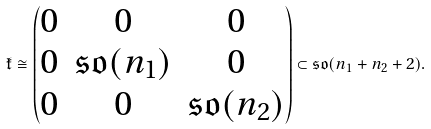<formula> <loc_0><loc_0><loc_500><loc_500>\mathfrak { k } \cong \begin{pmatrix} 0 & 0 & 0 \\ 0 & \mathfrak { s o } ( n _ { 1 } ) & 0 \\ 0 & 0 & \mathfrak { s o } ( n _ { 2 } ) \\ \end{pmatrix} \subset \mathfrak { s o } ( n _ { 1 } + n _ { 2 } + 2 ) .</formula> 